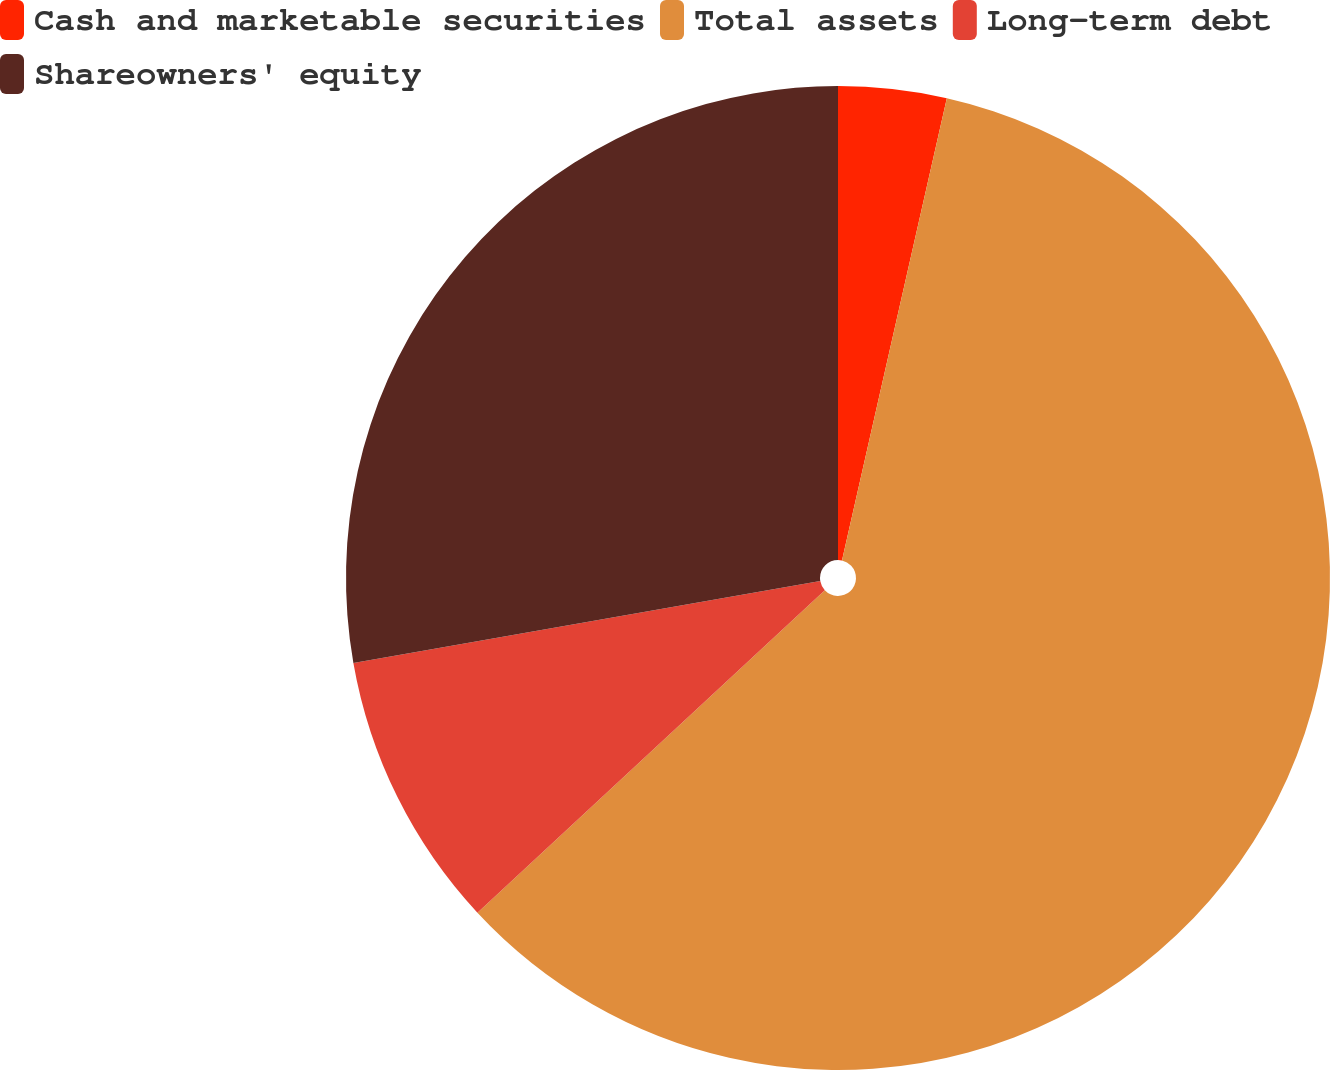Convert chart. <chart><loc_0><loc_0><loc_500><loc_500><pie_chart><fcel>Cash and marketable securities<fcel>Total assets<fcel>Long-term debt<fcel>Shareowners' equity<nl><fcel>3.55%<fcel>59.54%<fcel>9.15%<fcel>27.76%<nl></chart> 